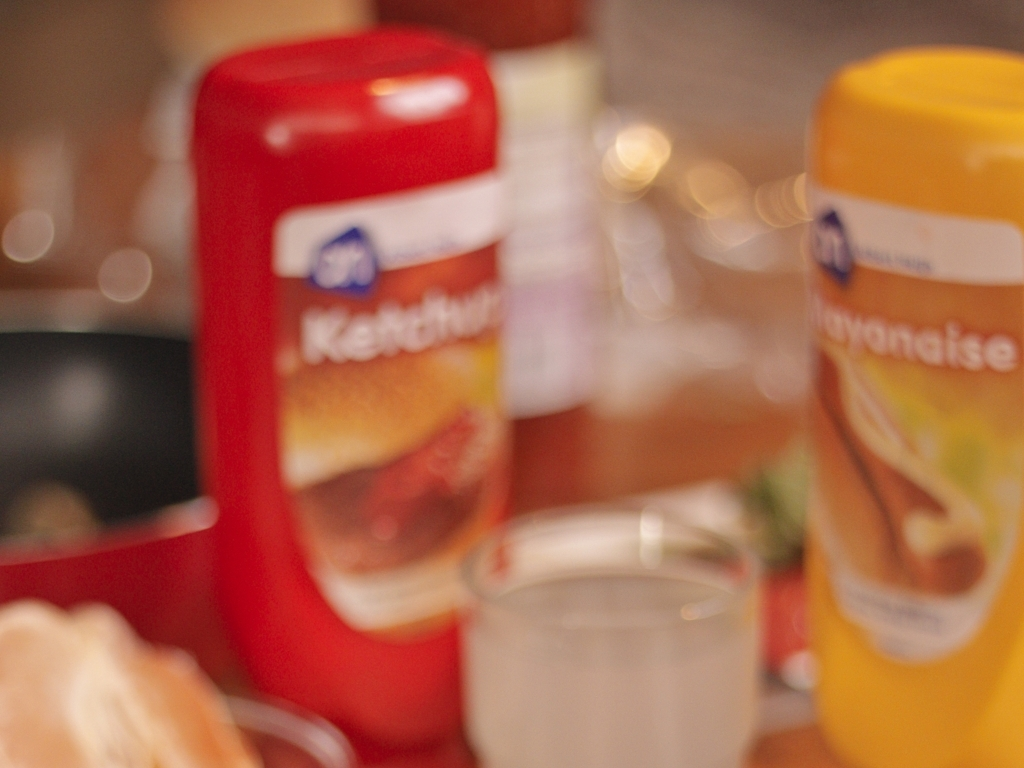What sort of atmosphere or feeling does the blurriness add to this image? The blurriness introduces a dreamy, soft, or nostalgic atmosphere to the image, perhaps suggesting a memory or a moment that is not entirely clear, giving it an artistic touch or emphasizing the fleetingness of the moment captured. 